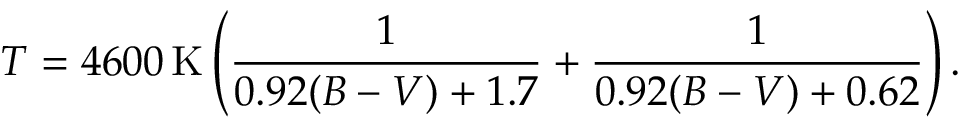Convert formula to latex. <formula><loc_0><loc_0><loc_500><loc_500>T = 4 6 0 0 \, K \left ( { \frac { 1 } { 0 . 9 2 ( B - V ) + 1 . 7 } } + { \frac { 1 } { 0 . 9 2 ( B - V ) + 0 . 6 2 } } \right ) .</formula> 